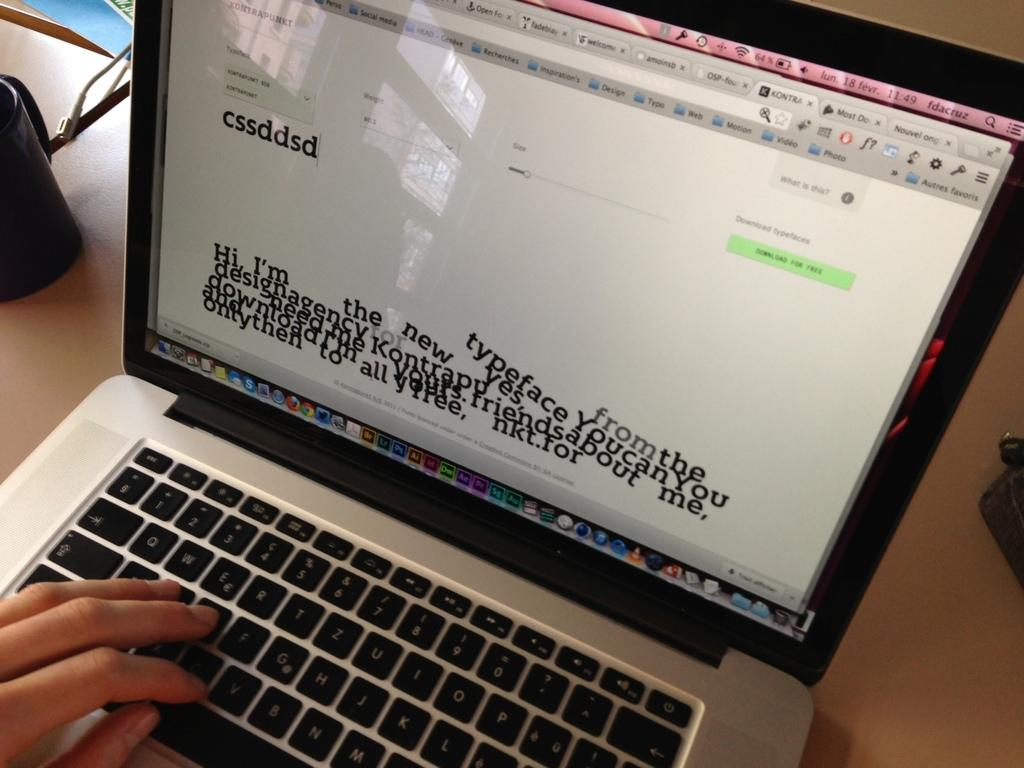<image>
Provide a brief description of the given image. A laptop screen shows a new typeface that you can download for free. 